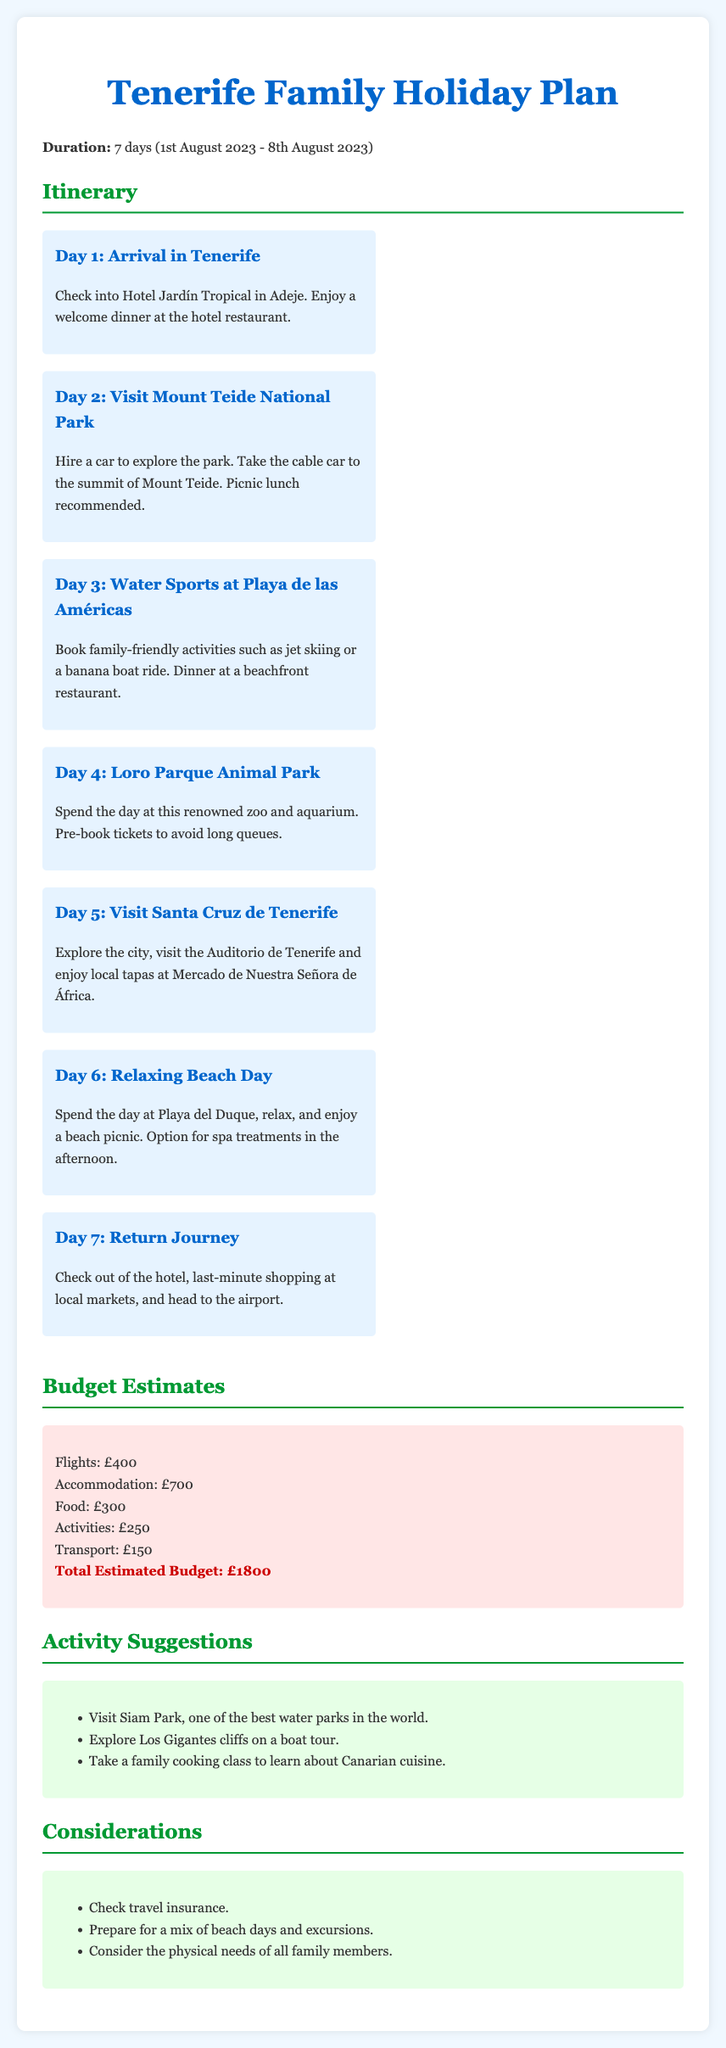What are the dates of the holiday? The holiday is scheduled for 1st August 2023 - 8th August 2023.
Answer: 1st August 2023 - 8th August 2023 How many days is the holiday? The document states the duration of the holiday as 7 days.
Answer: 7 days What is the total estimated budget? The total estimated budget is presented at the end of the budget estimates section in the document.
Answer: £1800 What is planned for Day 4? The itinerary for Day 4 mentions spending the day at Loro Parque Animal Park.
Answer: Loro Parque Animal Park What activity is suggested for Day 3? The document mentions booking family-friendly activities like jet skiing for Day 3.
Answer: Water Sports at Playa de las Américas Which hotel will the family check into? The name of the hotel where the family will stay is specified in the first day's itinerary.
Answer: Hotel Jardín Tropical What transport option is suggested for Day 2? The document states that hiring a car is recommended for exploring Mount Teide National Park on Day 2.
Answer: Hire a car What additional activity is suggested in the activity suggestions? One of the activities listed is exploring Los Gigantes cliffs on a boat tour.
Answer: Explore Los Gigantes cliffs on a boat tour What should be checked according to the considerations section? The considerations section advises checking travel insurance.
Answer: Travel insurance 